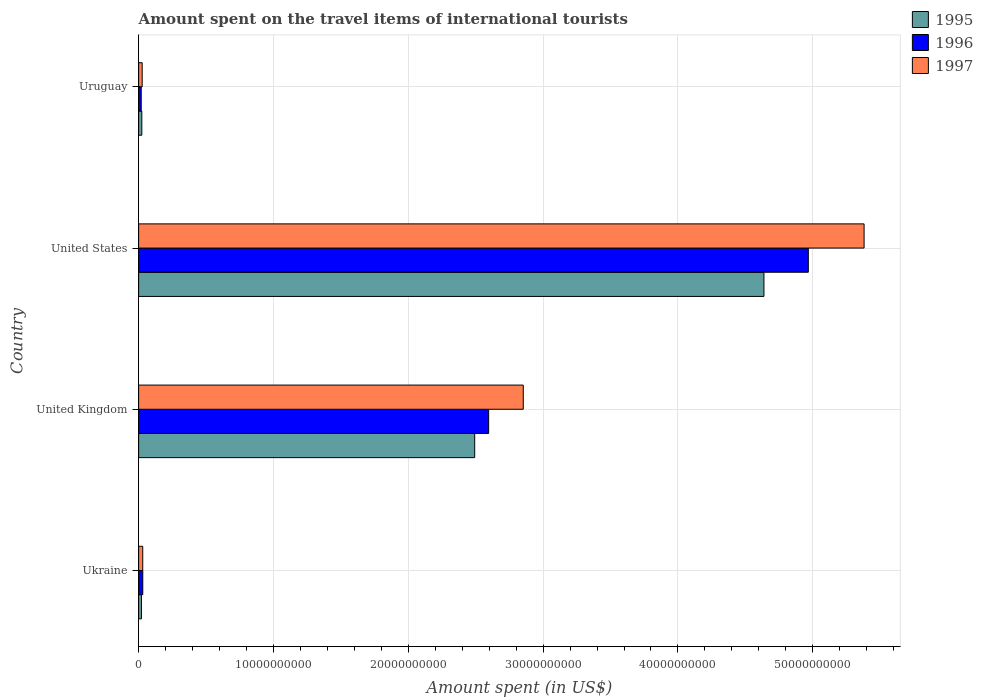How many different coloured bars are there?
Your answer should be compact. 3. How many groups of bars are there?
Your answer should be very brief. 4. Are the number of bars per tick equal to the number of legend labels?
Provide a short and direct response. Yes. How many bars are there on the 4th tick from the bottom?
Provide a short and direct response. 3. What is the label of the 3rd group of bars from the top?
Ensure brevity in your answer.  United Kingdom. In how many cases, is the number of bars for a given country not equal to the number of legend labels?
Provide a short and direct response. 0. What is the amount spent on the travel items of international tourists in 1995 in United States?
Give a very brief answer. 4.64e+1. Across all countries, what is the maximum amount spent on the travel items of international tourists in 1996?
Your answer should be compact. 4.97e+1. Across all countries, what is the minimum amount spent on the travel items of international tourists in 1996?
Ensure brevity in your answer.  1.92e+08. In which country was the amount spent on the travel items of international tourists in 1995 maximum?
Provide a succinct answer. United States. In which country was the amount spent on the travel items of international tourists in 1997 minimum?
Your answer should be compact. Uruguay. What is the total amount spent on the travel items of international tourists in 1997 in the graph?
Offer a terse response. 8.29e+1. What is the difference between the amount spent on the travel items of international tourists in 1997 in United Kingdom and that in Uruguay?
Give a very brief answer. 2.83e+1. What is the difference between the amount spent on the travel items of international tourists in 1995 in United Kingdom and the amount spent on the travel items of international tourists in 1997 in Uruguay?
Offer a terse response. 2.47e+1. What is the average amount spent on the travel items of international tourists in 1996 per country?
Ensure brevity in your answer.  1.90e+1. What is the difference between the amount spent on the travel items of international tourists in 1997 and amount spent on the travel items of international tourists in 1995 in United Kingdom?
Offer a very short reply. 3.60e+09. What is the ratio of the amount spent on the travel items of international tourists in 1995 in Ukraine to that in United Kingdom?
Offer a very short reply. 0.01. Is the difference between the amount spent on the travel items of international tourists in 1997 in United States and Uruguay greater than the difference between the amount spent on the travel items of international tourists in 1995 in United States and Uruguay?
Give a very brief answer. Yes. What is the difference between the highest and the second highest amount spent on the travel items of international tourists in 1995?
Provide a succinct answer. 2.15e+1. What is the difference between the highest and the lowest amount spent on the travel items of international tourists in 1995?
Offer a terse response. 4.62e+1. What does the 3rd bar from the bottom in Uruguay represents?
Offer a very short reply. 1997. Are all the bars in the graph horizontal?
Your response must be concise. Yes. How many countries are there in the graph?
Your response must be concise. 4. Where does the legend appear in the graph?
Provide a short and direct response. Top right. How many legend labels are there?
Offer a very short reply. 3. How are the legend labels stacked?
Your answer should be very brief. Vertical. What is the title of the graph?
Make the answer very short. Amount spent on the travel items of international tourists. Does "2002" appear as one of the legend labels in the graph?
Give a very brief answer. No. What is the label or title of the X-axis?
Offer a very short reply. Amount spent (in US$). What is the Amount spent (in US$) in 1995 in Ukraine?
Ensure brevity in your answer.  2.10e+08. What is the Amount spent (in US$) in 1996 in Ukraine?
Offer a very short reply. 3.08e+08. What is the Amount spent (in US$) of 1997 in Ukraine?
Your response must be concise. 3.05e+08. What is the Amount spent (in US$) in 1995 in United Kingdom?
Make the answer very short. 2.49e+1. What is the Amount spent (in US$) of 1996 in United Kingdom?
Provide a short and direct response. 2.60e+1. What is the Amount spent (in US$) in 1997 in United Kingdom?
Provide a succinct answer. 2.85e+1. What is the Amount spent (in US$) in 1995 in United States?
Give a very brief answer. 4.64e+1. What is the Amount spent (in US$) of 1996 in United States?
Ensure brevity in your answer.  4.97e+1. What is the Amount spent (in US$) in 1997 in United States?
Keep it short and to the point. 5.38e+1. What is the Amount spent (in US$) of 1995 in Uruguay?
Offer a very short reply. 2.36e+08. What is the Amount spent (in US$) of 1996 in Uruguay?
Ensure brevity in your answer.  1.92e+08. What is the Amount spent (in US$) of 1997 in Uruguay?
Give a very brief answer. 2.64e+08. Across all countries, what is the maximum Amount spent (in US$) in 1995?
Offer a very short reply. 4.64e+1. Across all countries, what is the maximum Amount spent (in US$) of 1996?
Ensure brevity in your answer.  4.97e+1. Across all countries, what is the maximum Amount spent (in US$) of 1997?
Offer a terse response. 5.38e+1. Across all countries, what is the minimum Amount spent (in US$) of 1995?
Keep it short and to the point. 2.10e+08. Across all countries, what is the minimum Amount spent (in US$) in 1996?
Provide a succinct answer. 1.92e+08. Across all countries, what is the minimum Amount spent (in US$) of 1997?
Your answer should be very brief. 2.64e+08. What is the total Amount spent (in US$) of 1995 in the graph?
Keep it short and to the point. 7.18e+1. What is the total Amount spent (in US$) of 1996 in the graph?
Your answer should be compact. 7.61e+1. What is the total Amount spent (in US$) of 1997 in the graph?
Provide a short and direct response. 8.29e+1. What is the difference between the Amount spent (in US$) of 1995 in Ukraine and that in United Kingdom?
Keep it short and to the point. -2.47e+1. What is the difference between the Amount spent (in US$) in 1996 in Ukraine and that in United Kingdom?
Provide a short and direct response. -2.57e+1. What is the difference between the Amount spent (in US$) in 1997 in Ukraine and that in United Kingdom?
Your answer should be very brief. -2.82e+1. What is the difference between the Amount spent (in US$) in 1995 in Ukraine and that in United States?
Offer a very short reply. -4.62e+1. What is the difference between the Amount spent (in US$) in 1996 in Ukraine and that in United States?
Give a very brief answer. -4.94e+1. What is the difference between the Amount spent (in US$) in 1997 in Ukraine and that in United States?
Provide a succinct answer. -5.35e+1. What is the difference between the Amount spent (in US$) of 1995 in Ukraine and that in Uruguay?
Your answer should be compact. -2.60e+07. What is the difference between the Amount spent (in US$) of 1996 in Ukraine and that in Uruguay?
Your answer should be compact. 1.16e+08. What is the difference between the Amount spent (in US$) in 1997 in Ukraine and that in Uruguay?
Offer a terse response. 4.10e+07. What is the difference between the Amount spent (in US$) of 1995 in United Kingdom and that in United States?
Make the answer very short. -2.15e+1. What is the difference between the Amount spent (in US$) in 1996 in United Kingdom and that in United States?
Ensure brevity in your answer.  -2.37e+1. What is the difference between the Amount spent (in US$) in 1997 in United Kingdom and that in United States?
Keep it short and to the point. -2.53e+1. What is the difference between the Amount spent (in US$) in 1995 in United Kingdom and that in Uruguay?
Provide a succinct answer. 2.47e+1. What is the difference between the Amount spent (in US$) in 1996 in United Kingdom and that in Uruguay?
Give a very brief answer. 2.58e+1. What is the difference between the Amount spent (in US$) of 1997 in United Kingdom and that in Uruguay?
Keep it short and to the point. 2.83e+1. What is the difference between the Amount spent (in US$) in 1995 in United States and that in Uruguay?
Keep it short and to the point. 4.61e+1. What is the difference between the Amount spent (in US$) in 1996 in United States and that in Uruguay?
Provide a short and direct response. 4.95e+1. What is the difference between the Amount spent (in US$) of 1997 in United States and that in Uruguay?
Ensure brevity in your answer.  5.35e+1. What is the difference between the Amount spent (in US$) of 1995 in Ukraine and the Amount spent (in US$) of 1996 in United Kingdom?
Your answer should be very brief. -2.58e+1. What is the difference between the Amount spent (in US$) in 1995 in Ukraine and the Amount spent (in US$) in 1997 in United Kingdom?
Your response must be concise. -2.83e+1. What is the difference between the Amount spent (in US$) in 1996 in Ukraine and the Amount spent (in US$) in 1997 in United Kingdom?
Provide a short and direct response. -2.82e+1. What is the difference between the Amount spent (in US$) in 1995 in Ukraine and the Amount spent (in US$) in 1996 in United States?
Your answer should be very brief. -4.95e+1. What is the difference between the Amount spent (in US$) in 1995 in Ukraine and the Amount spent (in US$) in 1997 in United States?
Ensure brevity in your answer.  -5.36e+1. What is the difference between the Amount spent (in US$) of 1996 in Ukraine and the Amount spent (in US$) of 1997 in United States?
Make the answer very short. -5.35e+1. What is the difference between the Amount spent (in US$) of 1995 in Ukraine and the Amount spent (in US$) of 1996 in Uruguay?
Ensure brevity in your answer.  1.80e+07. What is the difference between the Amount spent (in US$) in 1995 in Ukraine and the Amount spent (in US$) in 1997 in Uruguay?
Provide a succinct answer. -5.40e+07. What is the difference between the Amount spent (in US$) of 1996 in Ukraine and the Amount spent (in US$) of 1997 in Uruguay?
Give a very brief answer. 4.40e+07. What is the difference between the Amount spent (in US$) in 1995 in United Kingdom and the Amount spent (in US$) in 1996 in United States?
Your response must be concise. -2.47e+1. What is the difference between the Amount spent (in US$) of 1995 in United Kingdom and the Amount spent (in US$) of 1997 in United States?
Your answer should be very brief. -2.89e+1. What is the difference between the Amount spent (in US$) in 1996 in United Kingdom and the Amount spent (in US$) in 1997 in United States?
Offer a very short reply. -2.78e+1. What is the difference between the Amount spent (in US$) of 1995 in United Kingdom and the Amount spent (in US$) of 1996 in Uruguay?
Offer a very short reply. 2.47e+1. What is the difference between the Amount spent (in US$) in 1995 in United Kingdom and the Amount spent (in US$) in 1997 in Uruguay?
Give a very brief answer. 2.47e+1. What is the difference between the Amount spent (in US$) in 1996 in United Kingdom and the Amount spent (in US$) in 1997 in Uruguay?
Your response must be concise. 2.57e+1. What is the difference between the Amount spent (in US$) of 1995 in United States and the Amount spent (in US$) of 1996 in Uruguay?
Give a very brief answer. 4.62e+1. What is the difference between the Amount spent (in US$) in 1995 in United States and the Amount spent (in US$) in 1997 in Uruguay?
Your response must be concise. 4.61e+1. What is the difference between the Amount spent (in US$) in 1996 in United States and the Amount spent (in US$) in 1997 in Uruguay?
Make the answer very short. 4.94e+1. What is the average Amount spent (in US$) of 1995 per country?
Ensure brevity in your answer.  1.79e+1. What is the average Amount spent (in US$) in 1996 per country?
Your answer should be very brief. 1.90e+1. What is the average Amount spent (in US$) in 1997 per country?
Offer a terse response. 2.07e+1. What is the difference between the Amount spent (in US$) of 1995 and Amount spent (in US$) of 1996 in Ukraine?
Keep it short and to the point. -9.80e+07. What is the difference between the Amount spent (in US$) in 1995 and Amount spent (in US$) in 1997 in Ukraine?
Your response must be concise. -9.50e+07. What is the difference between the Amount spent (in US$) of 1995 and Amount spent (in US$) of 1996 in United Kingdom?
Offer a terse response. -1.04e+09. What is the difference between the Amount spent (in US$) in 1995 and Amount spent (in US$) in 1997 in United Kingdom?
Provide a succinct answer. -3.60e+09. What is the difference between the Amount spent (in US$) in 1996 and Amount spent (in US$) in 1997 in United Kingdom?
Keep it short and to the point. -2.57e+09. What is the difference between the Amount spent (in US$) in 1995 and Amount spent (in US$) in 1996 in United States?
Offer a very short reply. -3.29e+09. What is the difference between the Amount spent (in US$) in 1995 and Amount spent (in US$) in 1997 in United States?
Offer a very short reply. -7.43e+09. What is the difference between the Amount spent (in US$) in 1996 and Amount spent (in US$) in 1997 in United States?
Your response must be concise. -4.14e+09. What is the difference between the Amount spent (in US$) of 1995 and Amount spent (in US$) of 1996 in Uruguay?
Your answer should be very brief. 4.40e+07. What is the difference between the Amount spent (in US$) in 1995 and Amount spent (in US$) in 1997 in Uruguay?
Provide a succinct answer. -2.80e+07. What is the difference between the Amount spent (in US$) in 1996 and Amount spent (in US$) in 1997 in Uruguay?
Your response must be concise. -7.20e+07. What is the ratio of the Amount spent (in US$) of 1995 in Ukraine to that in United Kingdom?
Offer a very short reply. 0.01. What is the ratio of the Amount spent (in US$) of 1996 in Ukraine to that in United Kingdom?
Your answer should be very brief. 0.01. What is the ratio of the Amount spent (in US$) of 1997 in Ukraine to that in United Kingdom?
Provide a short and direct response. 0.01. What is the ratio of the Amount spent (in US$) of 1995 in Ukraine to that in United States?
Offer a very short reply. 0. What is the ratio of the Amount spent (in US$) in 1996 in Ukraine to that in United States?
Make the answer very short. 0.01. What is the ratio of the Amount spent (in US$) of 1997 in Ukraine to that in United States?
Keep it short and to the point. 0.01. What is the ratio of the Amount spent (in US$) in 1995 in Ukraine to that in Uruguay?
Ensure brevity in your answer.  0.89. What is the ratio of the Amount spent (in US$) in 1996 in Ukraine to that in Uruguay?
Give a very brief answer. 1.6. What is the ratio of the Amount spent (in US$) of 1997 in Ukraine to that in Uruguay?
Provide a succinct answer. 1.16. What is the ratio of the Amount spent (in US$) of 1995 in United Kingdom to that in United States?
Provide a succinct answer. 0.54. What is the ratio of the Amount spent (in US$) in 1996 in United Kingdom to that in United States?
Provide a short and direct response. 0.52. What is the ratio of the Amount spent (in US$) of 1997 in United Kingdom to that in United States?
Your answer should be very brief. 0.53. What is the ratio of the Amount spent (in US$) in 1995 in United Kingdom to that in Uruguay?
Offer a terse response. 105.62. What is the ratio of the Amount spent (in US$) in 1996 in United Kingdom to that in Uruguay?
Your answer should be compact. 135.22. What is the ratio of the Amount spent (in US$) in 1997 in United Kingdom to that in Uruguay?
Your answer should be very brief. 108.06. What is the ratio of the Amount spent (in US$) in 1995 in United States to that in Uruguay?
Provide a short and direct response. 196.52. What is the ratio of the Amount spent (in US$) in 1996 in United States to that in Uruguay?
Offer a terse response. 258.71. What is the ratio of the Amount spent (in US$) of 1997 in United States to that in Uruguay?
Your response must be concise. 203.82. What is the difference between the highest and the second highest Amount spent (in US$) of 1995?
Provide a short and direct response. 2.15e+1. What is the difference between the highest and the second highest Amount spent (in US$) of 1996?
Give a very brief answer. 2.37e+1. What is the difference between the highest and the second highest Amount spent (in US$) in 1997?
Offer a terse response. 2.53e+1. What is the difference between the highest and the lowest Amount spent (in US$) of 1995?
Offer a terse response. 4.62e+1. What is the difference between the highest and the lowest Amount spent (in US$) in 1996?
Offer a terse response. 4.95e+1. What is the difference between the highest and the lowest Amount spent (in US$) of 1997?
Keep it short and to the point. 5.35e+1. 